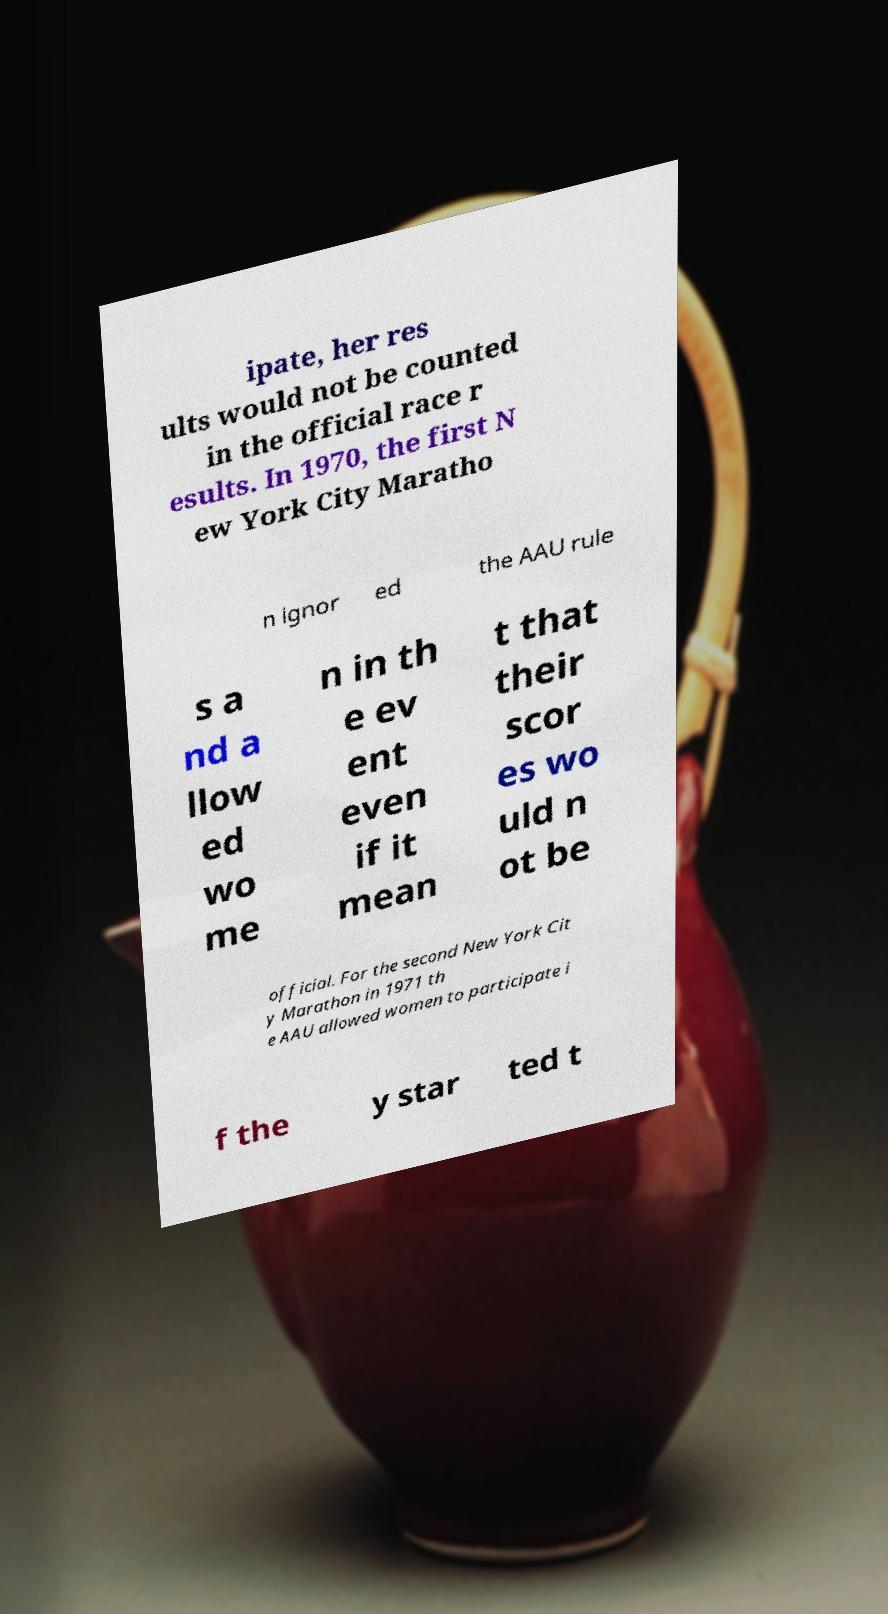Please read and relay the text visible in this image. What does it say? ipate, her res ults would not be counted in the official race r esults. In 1970, the first N ew York City Maratho n ignor ed the AAU rule s a nd a llow ed wo me n in th e ev ent even if it mean t that their scor es wo uld n ot be official. For the second New York Cit y Marathon in 1971 th e AAU allowed women to participate i f the y star ted t 